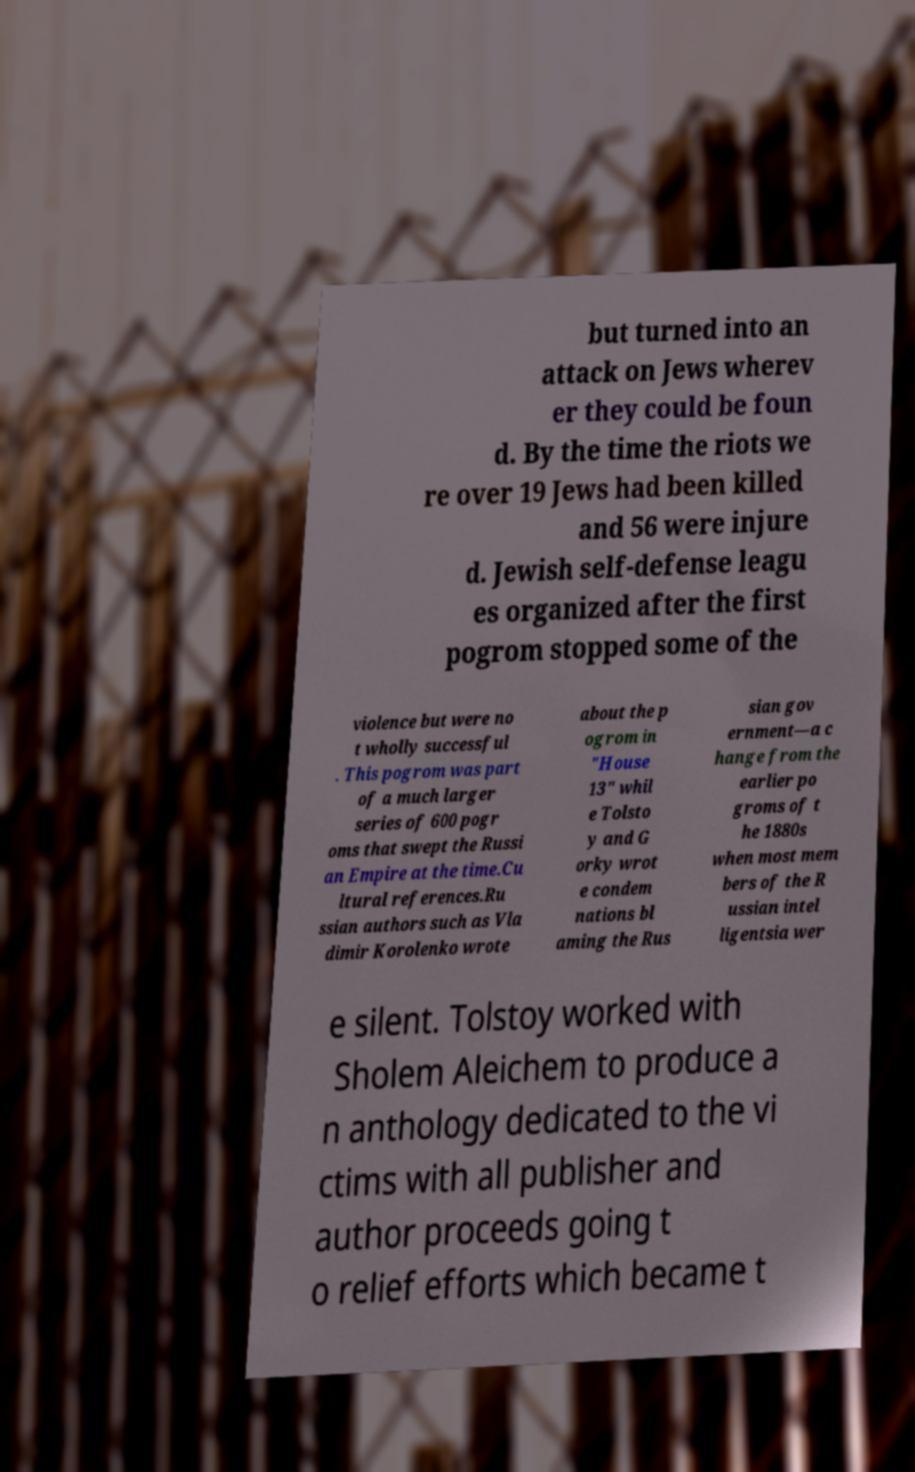Could you assist in decoding the text presented in this image and type it out clearly? but turned into an attack on Jews wherev er they could be foun d. By the time the riots we re over 19 Jews had been killed and 56 were injure d. Jewish self-defense leagu es organized after the first pogrom stopped some of the violence but were no t wholly successful . This pogrom was part of a much larger series of 600 pogr oms that swept the Russi an Empire at the time.Cu ltural references.Ru ssian authors such as Vla dimir Korolenko wrote about the p ogrom in "House 13" whil e Tolsto y and G orky wrot e condem nations bl aming the Rus sian gov ernment—a c hange from the earlier po groms of t he 1880s when most mem bers of the R ussian intel ligentsia wer e silent. Tolstoy worked with Sholem Aleichem to produce a n anthology dedicated to the vi ctims with all publisher and author proceeds going t o relief efforts which became t 